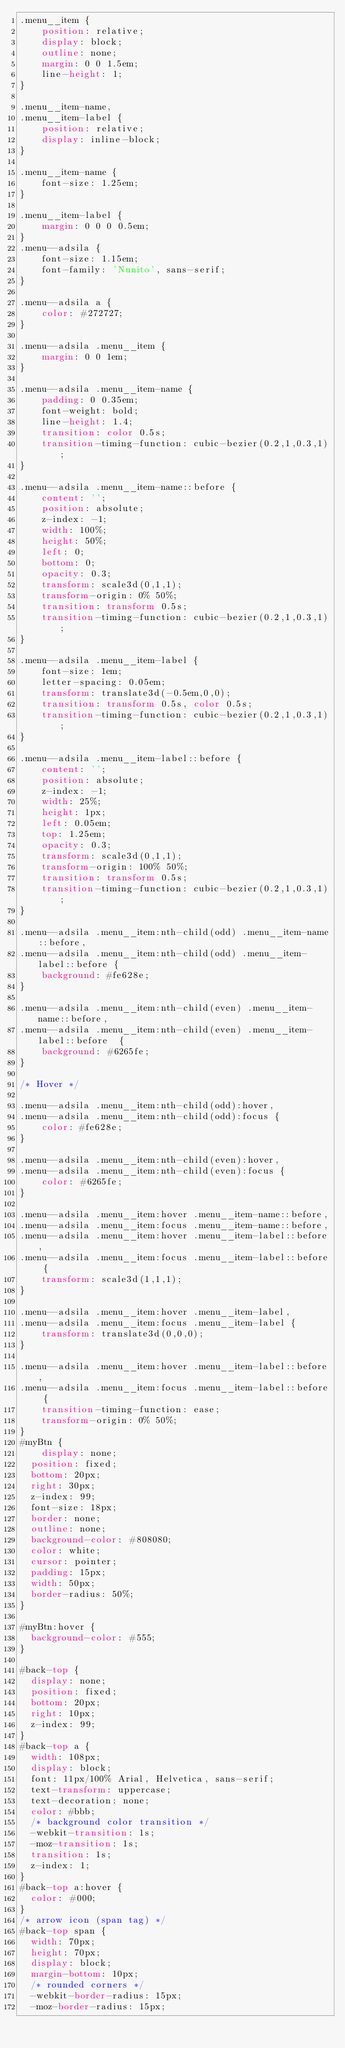<code> <loc_0><loc_0><loc_500><loc_500><_CSS_>.menu__item {
	position: relative;
	display: block;
	outline: none;
	margin: 0 0 1.5em;
	line-height: 1;
}

.menu__item-name,
.menu__item-label {
	position: relative;
	display: inline-block;
}

.menu__item-name {
	font-size: 1.25em;
}

.menu__item-label {
	margin: 0 0 0 0.5em;
}
.menu--adsila {
	font-size: 1.15em;
	font-family: 'Nunito', sans-serif;
}

.menu--adsila a {
	color: #272727;
}

.menu--adsila .menu__item {
	margin: 0 0 1em;
}

.menu--adsila .menu__item-name {
	padding: 0 0.35em;
	font-weight: bold;
	line-height: 1.4;
	transition: color 0.5s;
	transition-timing-function: cubic-bezier(0.2,1,0.3,1);
}

.menu--adsila .menu__item-name::before {
	content: '';
	position: absolute;
	z-index: -1;
	width: 100%;
	height: 50%;
	left: 0;
	bottom: 0;
	opacity: 0.3;
	transform: scale3d(0,1,1);
	transform-origin: 0% 50%;
	transition: transform 0.5s;
	transition-timing-function: cubic-bezier(0.2,1,0.3,1);
}

.menu--adsila .menu__item-label {
	font-size: 1em;
	letter-spacing: 0.05em;
	transform: translate3d(-0.5em,0,0);
	transition: transform 0.5s, color 0.5s;
	transition-timing-function: cubic-bezier(0.2,1,0.3,1);
}

.menu--adsila .menu__item-label::before {
	content: '';
	position: absolute;
	z-index: -1;
	width: 25%;
	height: 1px;
	left: 0.05em;
	top: 1.25em;
	opacity: 0.3;
	transform: scale3d(0,1,1);
	transform-origin: 100% 50%;
	transition: transform 0.5s;
	transition-timing-function: cubic-bezier(0.2,1,0.3,1);
}

.menu--adsila .menu__item:nth-child(odd) .menu__item-name::before,
.menu--adsila .menu__item:nth-child(odd) .menu__item-label::before {
	background: #fe628e;
}

.menu--adsila .menu__item:nth-child(even) .menu__item-name::before,
.menu--adsila .menu__item:nth-child(even) .menu__item-label::before  {
	background: #6265fe;
}

/* Hover */

.menu--adsila .menu__item:nth-child(odd):hover,
.menu--adsila .menu__item:nth-child(odd):focus {
	color: #fe628e;
}

.menu--adsila .menu__item:nth-child(even):hover,
.menu--adsila .menu__item:nth-child(even):focus {
	color: #6265fe;
}

.menu--adsila .menu__item:hover .menu__item-name::before,
.menu--adsila .menu__item:focus .menu__item-name::before,
.menu--adsila .menu__item:hover .menu__item-label::before,
.menu--adsila .menu__item:focus .menu__item-label::before {
	transform: scale3d(1,1,1);
}

.menu--adsila .menu__item:hover .menu__item-label,
.menu--adsila .menu__item:focus .menu__item-label {
	transform: translate3d(0,0,0);
}

.menu--adsila .menu__item:hover .menu__item-label::before,
.menu--adsila .menu__item:focus .menu__item-label::before {
	transition-timing-function: ease;
	transform-origin: 0% 50%;
}
#myBtn {
	display: none;
  position: fixed;
  bottom: 20px;
  right: 30px;
  z-index: 99;
  font-size: 18px;
  border: none;
  outline: none;
  background-color: #808080;
  color: white;
  cursor: pointer;
  padding: 15px;
  width: 50px;
  border-radius: 50%;
}

#myBtn:hover {
  background-color: #555;
}

#back-top {
  display: none;
  position: fixed;
  bottom: 20px;
  right: 10px;
  z-index: 99;
}
#back-top a {
  width: 108px;
  display: block;
  font: 11px/100% Arial, Helvetica, sans-serif;
  text-transform: uppercase;
  text-decoration: none;
  color: #bbb;
  /* background color transition */
  -webkit-transition: 1s;
  -moz-transition: 1s;
  transition: 1s;
  z-index: 1;
}
#back-top a:hover {
  color: #000;
}
/* arrow icon (span tag) */
#back-top span {
  width: 70px;
  height: 70px;
  display: block;
  margin-bottom: 10px;
  /* rounded corners */
  -webkit-border-radius: 15px;
  -moz-border-radius: 15px;</code> 